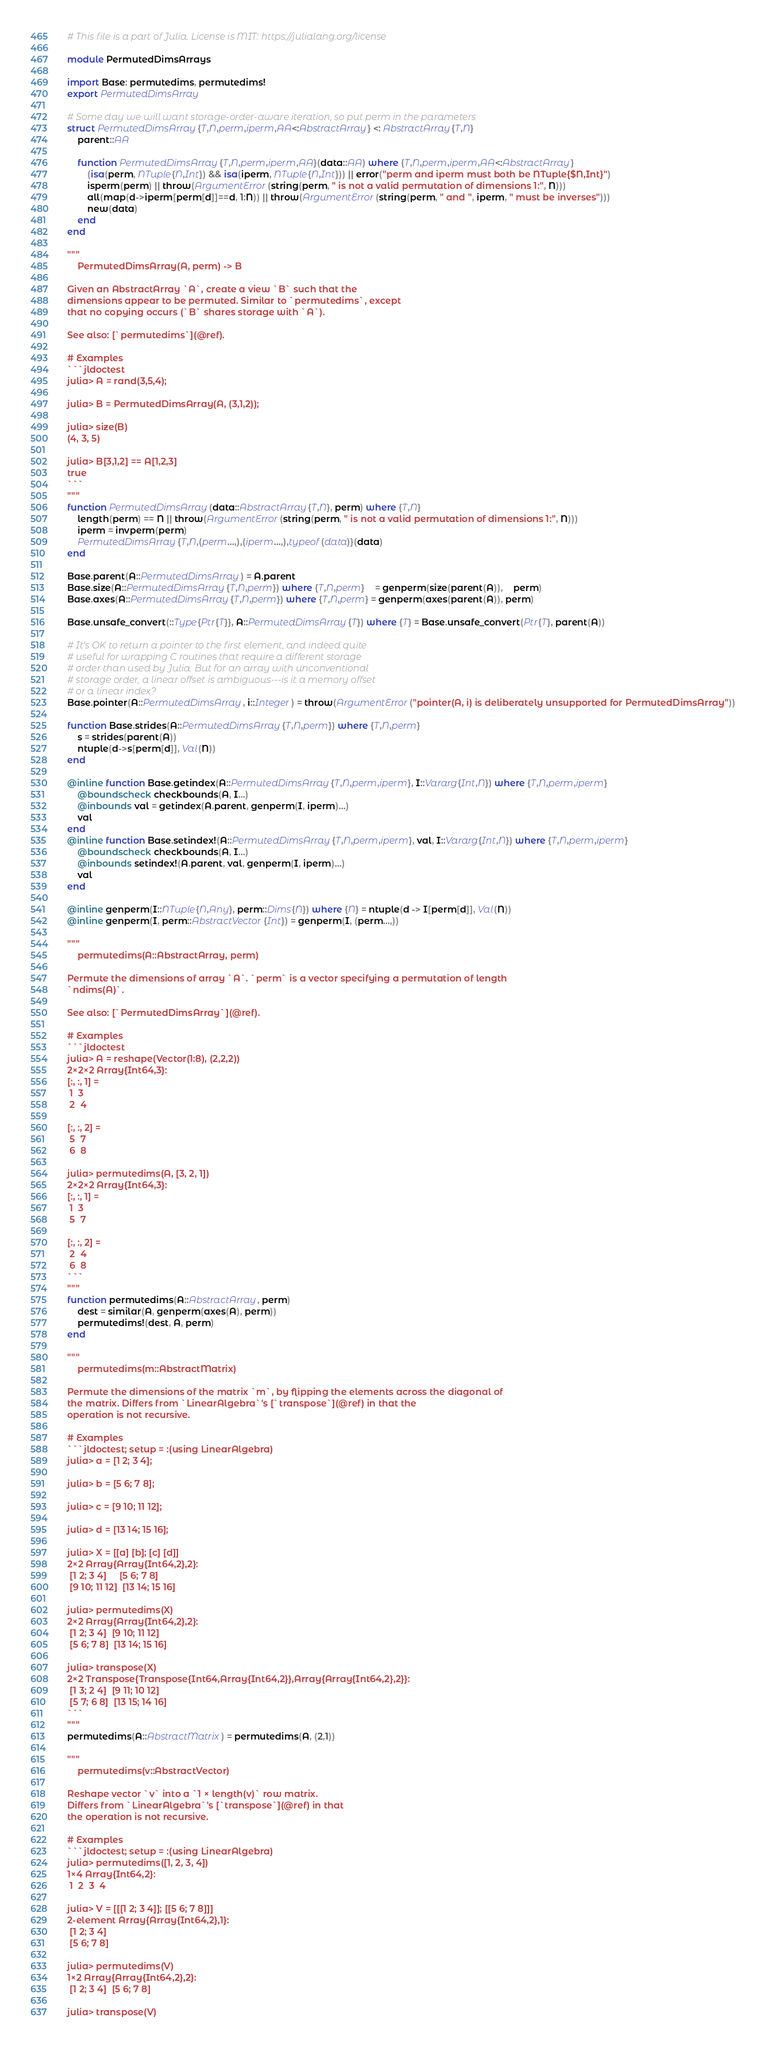Convert code to text. <code><loc_0><loc_0><loc_500><loc_500><_Julia_># This file is a part of Julia. License is MIT: https://julialang.org/license

module PermutedDimsArrays

import Base: permutedims, permutedims!
export PermutedDimsArray

# Some day we will want storage-order-aware iteration, so put perm in the parameters
struct PermutedDimsArray{T,N,perm,iperm,AA<:AbstractArray} <: AbstractArray{T,N}
    parent::AA

    function PermutedDimsArray{T,N,perm,iperm,AA}(data::AA) where {T,N,perm,iperm,AA<:AbstractArray}
        (isa(perm, NTuple{N,Int}) && isa(iperm, NTuple{N,Int})) || error("perm and iperm must both be NTuple{$N,Int}")
        isperm(perm) || throw(ArgumentError(string(perm, " is not a valid permutation of dimensions 1:", N)))
        all(map(d->iperm[perm[d]]==d, 1:N)) || throw(ArgumentError(string(perm, " and ", iperm, " must be inverses")))
        new(data)
    end
end

"""
    PermutedDimsArray(A, perm) -> B

Given an AbstractArray `A`, create a view `B` such that the
dimensions appear to be permuted. Similar to `permutedims`, except
that no copying occurs (`B` shares storage with `A`).

See also: [`permutedims`](@ref).

# Examples
```jldoctest
julia> A = rand(3,5,4);

julia> B = PermutedDimsArray(A, (3,1,2));

julia> size(B)
(4, 3, 5)

julia> B[3,1,2] == A[1,2,3]
true
```
"""
function PermutedDimsArray(data::AbstractArray{T,N}, perm) where {T,N}
    length(perm) == N || throw(ArgumentError(string(perm, " is not a valid permutation of dimensions 1:", N)))
    iperm = invperm(perm)
    PermutedDimsArray{T,N,(perm...,),(iperm...,),typeof(data)}(data)
end

Base.parent(A::PermutedDimsArray) = A.parent
Base.size(A::PermutedDimsArray{T,N,perm}) where {T,N,perm}    = genperm(size(parent(A)),    perm)
Base.axes(A::PermutedDimsArray{T,N,perm}) where {T,N,perm} = genperm(axes(parent(A)), perm)

Base.unsafe_convert(::Type{Ptr{T}}, A::PermutedDimsArray{T}) where {T} = Base.unsafe_convert(Ptr{T}, parent(A))

# It's OK to return a pointer to the first element, and indeed quite
# useful for wrapping C routines that require a different storage
# order than used by Julia. But for an array with unconventional
# storage order, a linear offset is ambiguous---is it a memory offset
# or a linear index?
Base.pointer(A::PermutedDimsArray, i::Integer) = throw(ArgumentError("pointer(A, i) is deliberately unsupported for PermutedDimsArray"))

function Base.strides(A::PermutedDimsArray{T,N,perm}) where {T,N,perm}
    s = strides(parent(A))
    ntuple(d->s[perm[d]], Val(N))
end

@inline function Base.getindex(A::PermutedDimsArray{T,N,perm,iperm}, I::Vararg{Int,N}) where {T,N,perm,iperm}
    @boundscheck checkbounds(A, I...)
    @inbounds val = getindex(A.parent, genperm(I, iperm)...)
    val
end
@inline function Base.setindex!(A::PermutedDimsArray{T,N,perm,iperm}, val, I::Vararg{Int,N}) where {T,N,perm,iperm}
    @boundscheck checkbounds(A, I...)
    @inbounds setindex!(A.parent, val, genperm(I, iperm)...)
    val
end

@inline genperm(I::NTuple{N,Any}, perm::Dims{N}) where {N} = ntuple(d -> I[perm[d]], Val(N))
@inline genperm(I, perm::AbstractVector{Int}) = genperm(I, (perm...,))

"""
    permutedims(A::AbstractArray, perm)

Permute the dimensions of array `A`. `perm` is a vector specifying a permutation of length
`ndims(A)`.

See also: [`PermutedDimsArray`](@ref).

# Examples
```jldoctest
julia> A = reshape(Vector(1:8), (2,2,2))
2×2×2 Array{Int64,3}:
[:, :, 1] =
 1  3
 2  4

[:, :, 2] =
 5  7
 6  8

julia> permutedims(A, [3, 2, 1])
2×2×2 Array{Int64,3}:
[:, :, 1] =
 1  3
 5  7

[:, :, 2] =
 2  4
 6  8
```
"""
function permutedims(A::AbstractArray, perm)
    dest = similar(A, genperm(axes(A), perm))
    permutedims!(dest, A, perm)
end

"""
    permutedims(m::AbstractMatrix)

Permute the dimensions of the matrix `m`, by flipping the elements across the diagonal of
the matrix. Differs from `LinearAlgebra`'s [`transpose`](@ref) in that the
operation is not recursive.

# Examples
```jldoctest; setup = :(using LinearAlgebra)
julia> a = [1 2; 3 4];

julia> b = [5 6; 7 8];

julia> c = [9 10; 11 12];

julia> d = [13 14; 15 16];

julia> X = [[a] [b]; [c] [d]]
2×2 Array{Array{Int64,2},2}:
 [1 2; 3 4]     [5 6; 7 8]
 [9 10; 11 12]  [13 14; 15 16]

julia> permutedims(X)
2×2 Array{Array{Int64,2},2}:
 [1 2; 3 4]  [9 10; 11 12]
 [5 6; 7 8]  [13 14; 15 16]

julia> transpose(X)
2×2 Transpose{Transpose{Int64,Array{Int64,2}},Array{Array{Int64,2},2}}:
 [1 3; 2 4]  [9 11; 10 12]
 [5 7; 6 8]  [13 15; 14 16]
```
"""
permutedims(A::AbstractMatrix) = permutedims(A, (2,1))

"""
    permutedims(v::AbstractVector)

Reshape vector `v` into a `1 × length(v)` row matrix.
Differs from `LinearAlgebra`'s [`transpose`](@ref) in that
the operation is not recursive.

# Examples
```jldoctest; setup = :(using LinearAlgebra)
julia> permutedims([1, 2, 3, 4])
1×4 Array{Int64,2}:
 1  2  3  4

julia> V = [[[1 2; 3 4]]; [[5 6; 7 8]]]
2-element Array{Array{Int64,2},1}:
 [1 2; 3 4]
 [5 6; 7 8]

julia> permutedims(V)
1×2 Array{Array{Int64,2},2}:
 [1 2; 3 4]  [5 6; 7 8]

julia> transpose(V)</code> 